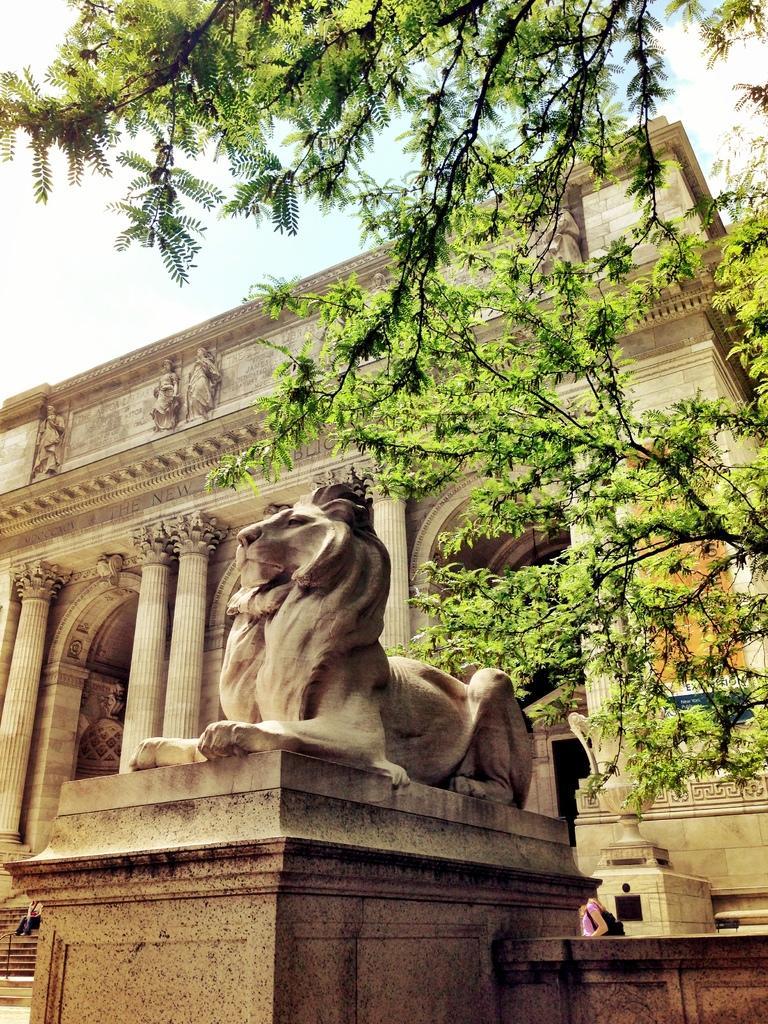In one or two sentences, can you explain what this image depicts? In the center of the image we can see statue. In the background we can see tree, building and sky. 